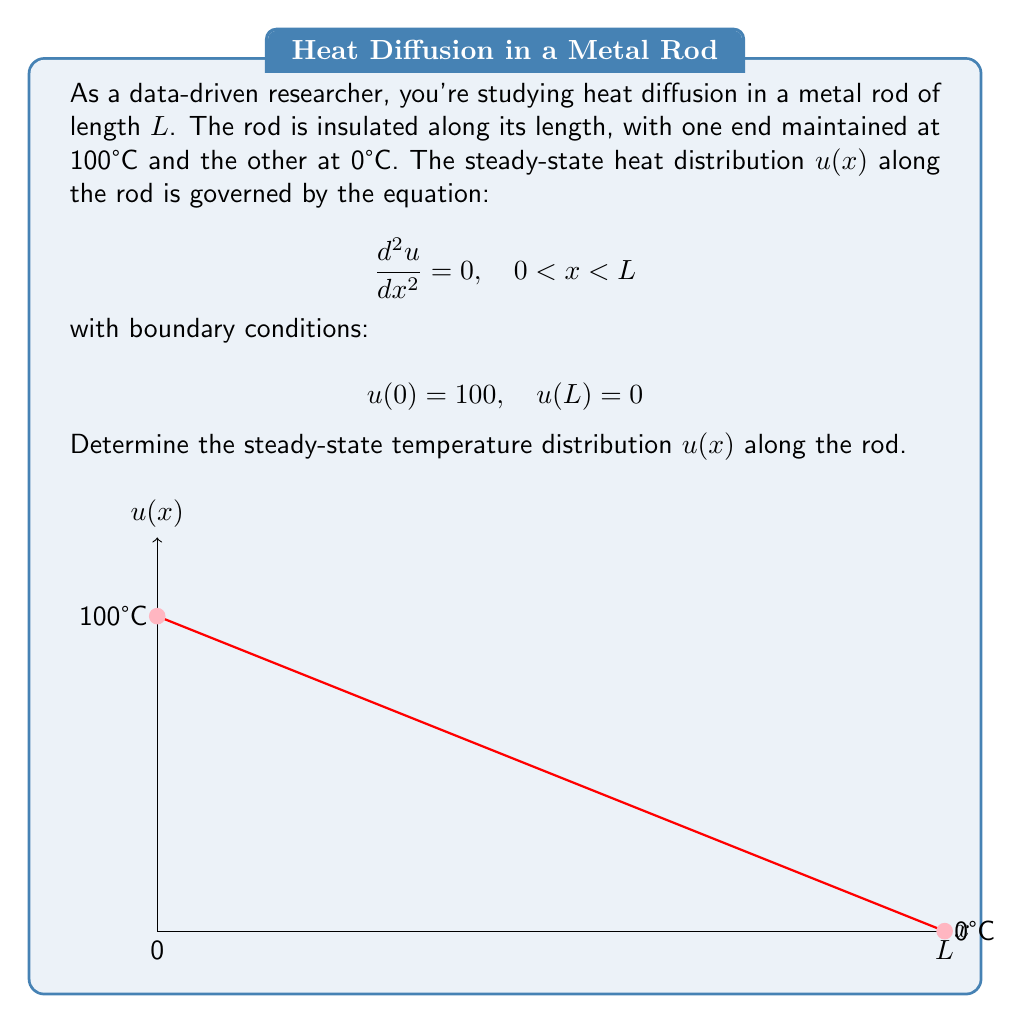What is the answer to this math problem? To solve this boundary value problem, we'll follow these steps:

1) The general solution to the differential equation $\frac{d^2u}{dx^2} = 0$ is:

   $$u(x) = Ax + B$$

   where A and B are constants to be determined.

2) Apply the boundary conditions:
   At x = 0: $u(0) = 100 = B$
   At x = L: $u(L) = 0 = AL + 100$

3) From the second condition:
   $$AL + 100 = 0$$
   $$AL = -100$$
   $$A = -\frac{100}{L}$$

4) Therefore, the steady-state temperature distribution is:

   $$u(x) = -\frac{100}{L}x + 100$$

5) This represents a linear decrease in temperature from 100°C at x = 0 to 0°C at x = L.
Answer: $u(x) = -\frac{100}{L}x + 100$ 